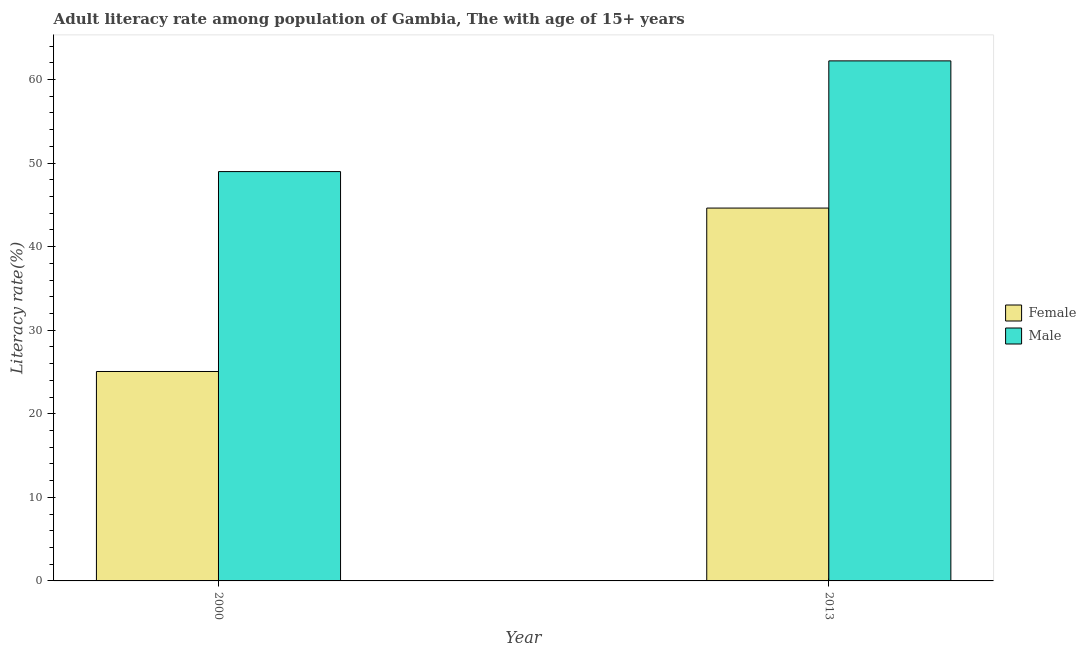Are the number of bars per tick equal to the number of legend labels?
Offer a terse response. Yes. Are the number of bars on each tick of the X-axis equal?
Offer a very short reply. Yes. How many bars are there on the 2nd tick from the right?
Offer a very short reply. 2. In how many cases, is the number of bars for a given year not equal to the number of legend labels?
Keep it short and to the point. 0. What is the female adult literacy rate in 2000?
Offer a very short reply. 25.06. Across all years, what is the maximum female adult literacy rate?
Keep it short and to the point. 44.62. Across all years, what is the minimum female adult literacy rate?
Your answer should be compact. 25.06. In which year was the male adult literacy rate minimum?
Provide a succinct answer. 2000. What is the total female adult literacy rate in the graph?
Your answer should be very brief. 69.68. What is the difference between the female adult literacy rate in 2000 and that in 2013?
Offer a very short reply. -19.55. What is the difference between the male adult literacy rate in 2013 and the female adult literacy rate in 2000?
Ensure brevity in your answer.  13.25. What is the average female adult literacy rate per year?
Provide a short and direct response. 34.84. In how many years, is the male adult literacy rate greater than 2 %?
Keep it short and to the point. 2. What is the ratio of the male adult literacy rate in 2000 to that in 2013?
Provide a short and direct response. 0.79. Is the female adult literacy rate in 2000 less than that in 2013?
Your answer should be compact. Yes. What does the 2nd bar from the left in 2013 represents?
Your answer should be compact. Male. What does the 1st bar from the right in 2013 represents?
Provide a succinct answer. Male. Are all the bars in the graph horizontal?
Offer a very short reply. No. What is the difference between two consecutive major ticks on the Y-axis?
Offer a very short reply. 10. Are the values on the major ticks of Y-axis written in scientific E-notation?
Provide a succinct answer. No. Does the graph contain any zero values?
Provide a succinct answer. No. Where does the legend appear in the graph?
Your answer should be compact. Center right. How many legend labels are there?
Provide a short and direct response. 2. How are the legend labels stacked?
Ensure brevity in your answer.  Vertical. What is the title of the graph?
Offer a terse response. Adult literacy rate among population of Gambia, The with age of 15+ years. Does "Nitrous oxide" appear as one of the legend labels in the graph?
Offer a terse response. No. What is the label or title of the X-axis?
Ensure brevity in your answer.  Year. What is the label or title of the Y-axis?
Offer a terse response. Literacy rate(%). What is the Literacy rate(%) in Female in 2000?
Keep it short and to the point. 25.06. What is the Literacy rate(%) in Male in 2000?
Offer a terse response. 48.98. What is the Literacy rate(%) in Female in 2013?
Your answer should be very brief. 44.62. What is the Literacy rate(%) in Male in 2013?
Ensure brevity in your answer.  62.23. Across all years, what is the maximum Literacy rate(%) in Female?
Ensure brevity in your answer.  44.62. Across all years, what is the maximum Literacy rate(%) in Male?
Offer a very short reply. 62.23. Across all years, what is the minimum Literacy rate(%) of Female?
Offer a terse response. 25.06. Across all years, what is the minimum Literacy rate(%) in Male?
Give a very brief answer. 48.98. What is the total Literacy rate(%) in Female in the graph?
Keep it short and to the point. 69.68. What is the total Literacy rate(%) in Male in the graph?
Provide a succinct answer. 111.21. What is the difference between the Literacy rate(%) in Female in 2000 and that in 2013?
Offer a very short reply. -19.55. What is the difference between the Literacy rate(%) in Male in 2000 and that in 2013?
Your response must be concise. -13.25. What is the difference between the Literacy rate(%) in Female in 2000 and the Literacy rate(%) in Male in 2013?
Your response must be concise. -37.17. What is the average Literacy rate(%) of Female per year?
Your response must be concise. 34.84. What is the average Literacy rate(%) of Male per year?
Offer a terse response. 55.61. In the year 2000, what is the difference between the Literacy rate(%) in Female and Literacy rate(%) in Male?
Your response must be concise. -23.92. In the year 2013, what is the difference between the Literacy rate(%) of Female and Literacy rate(%) of Male?
Keep it short and to the point. -17.61. What is the ratio of the Literacy rate(%) of Female in 2000 to that in 2013?
Give a very brief answer. 0.56. What is the ratio of the Literacy rate(%) in Male in 2000 to that in 2013?
Your answer should be very brief. 0.79. What is the difference between the highest and the second highest Literacy rate(%) of Female?
Offer a very short reply. 19.55. What is the difference between the highest and the second highest Literacy rate(%) in Male?
Offer a very short reply. 13.25. What is the difference between the highest and the lowest Literacy rate(%) of Female?
Offer a terse response. 19.55. What is the difference between the highest and the lowest Literacy rate(%) of Male?
Provide a short and direct response. 13.25. 